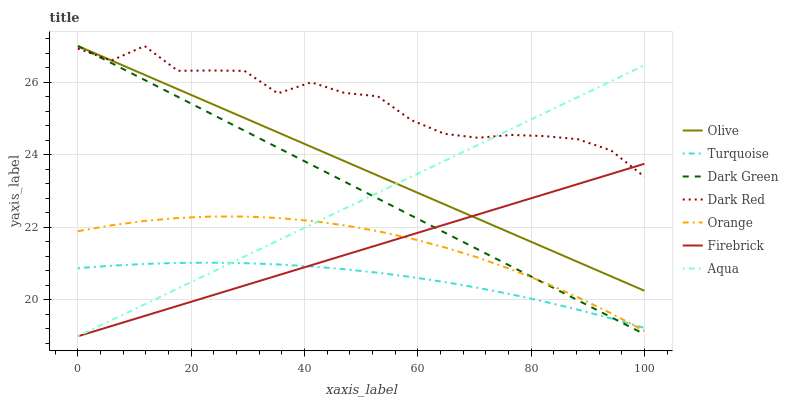Does Turquoise have the minimum area under the curve?
Answer yes or no. Yes. Does Dark Red have the maximum area under the curve?
Answer yes or no. Yes. Does Firebrick have the minimum area under the curve?
Answer yes or no. No. Does Firebrick have the maximum area under the curve?
Answer yes or no. No. Is Olive the smoothest?
Answer yes or no. Yes. Is Dark Red the roughest?
Answer yes or no. Yes. Is Firebrick the smoothest?
Answer yes or no. No. Is Firebrick the roughest?
Answer yes or no. No. Does Dark Red have the lowest value?
Answer yes or no. No. Does Dark Green have the highest value?
Answer yes or no. Yes. Does Firebrick have the highest value?
Answer yes or no. No. Is Orange less than Olive?
Answer yes or no. Yes. Is Olive greater than Orange?
Answer yes or no. Yes. Does Firebrick intersect Olive?
Answer yes or no. Yes. Is Firebrick less than Olive?
Answer yes or no. No. Is Firebrick greater than Olive?
Answer yes or no. No. Does Orange intersect Olive?
Answer yes or no. No. 